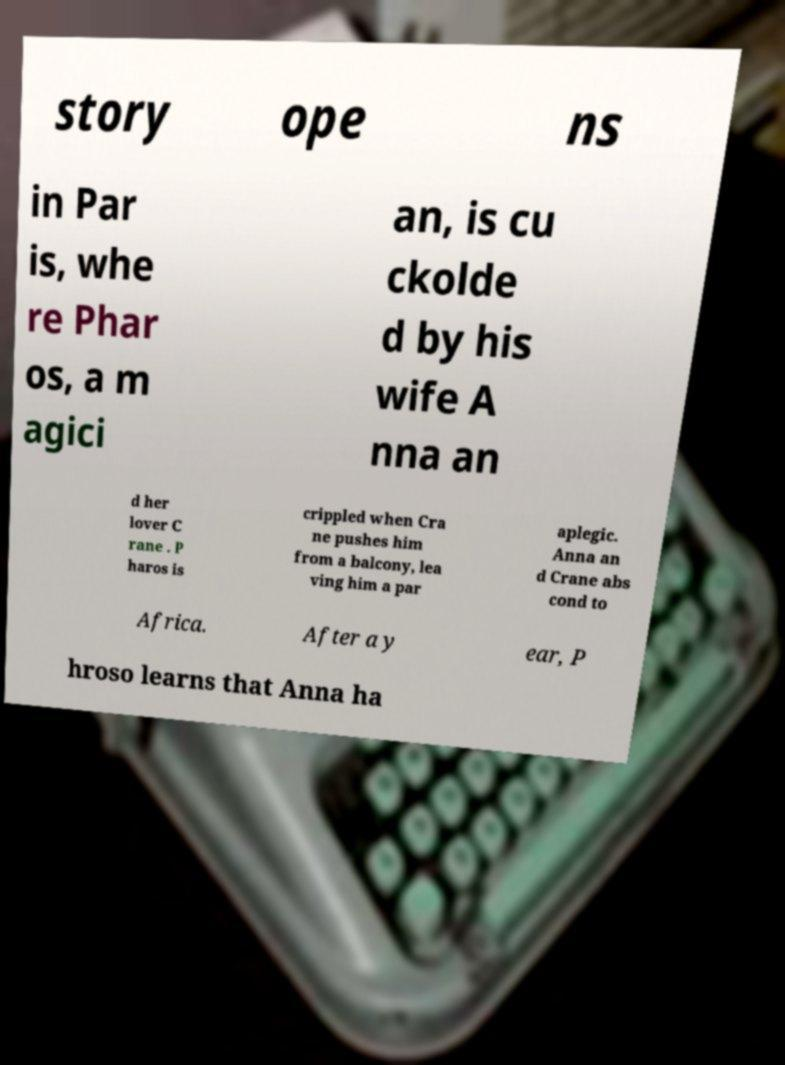What messages or text are displayed in this image? I need them in a readable, typed format. story ope ns in Par is, whe re Phar os, a m agici an, is cu ckolde d by his wife A nna an d her lover C rane . P haros is crippled when Cra ne pushes him from a balcony, lea ving him a par aplegic. Anna an d Crane abs cond to Africa. After a y ear, P hroso learns that Anna ha 